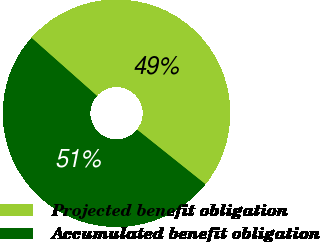Convert chart to OTSL. <chart><loc_0><loc_0><loc_500><loc_500><pie_chart><fcel>Projected benefit obligation<fcel>Accumulated benefit obligation<nl><fcel>49.18%<fcel>50.82%<nl></chart> 